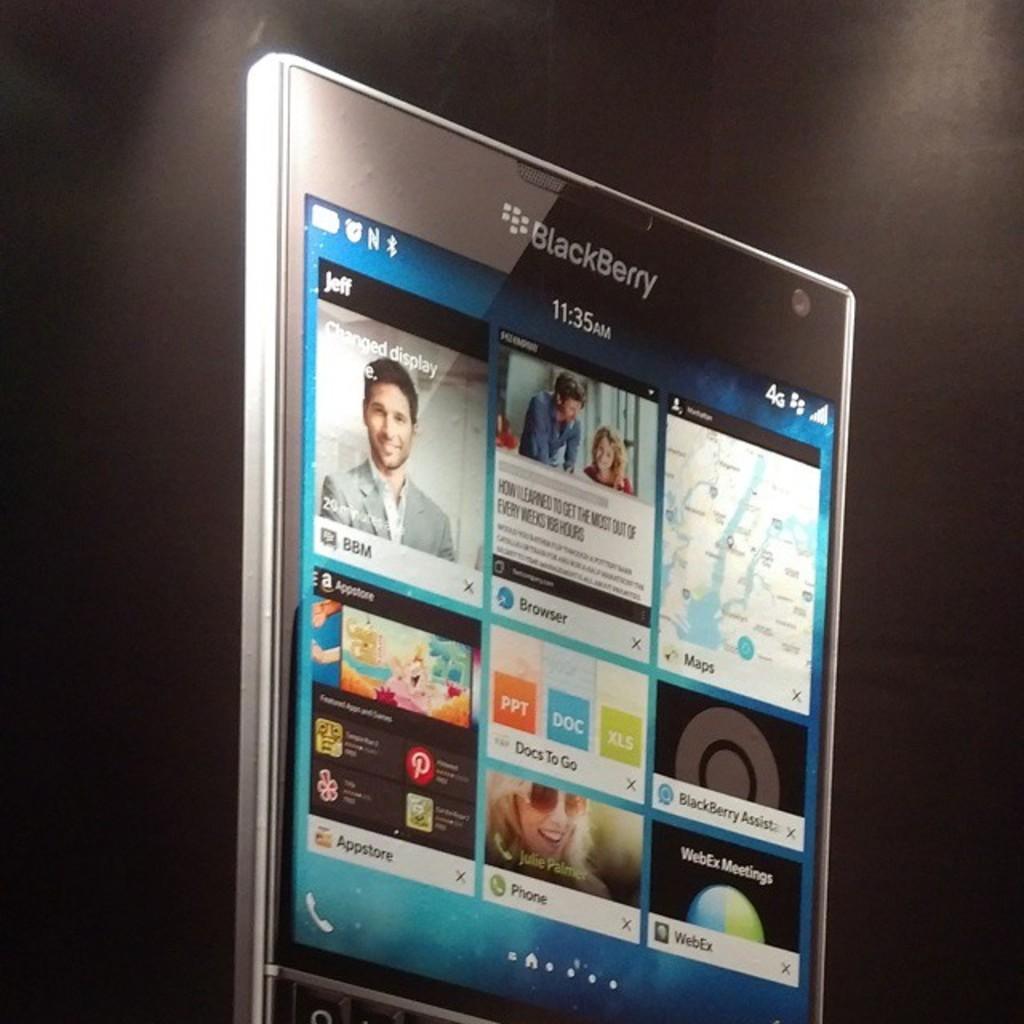Can you describe this image briefly? In the picture I can see a mobile phone. On the screen of a mobile phone I can see the applications and icons. 